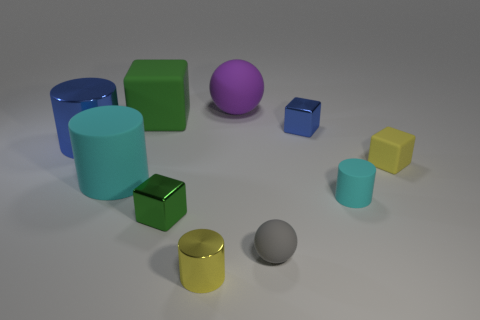What number of tiny things are in front of the big cyan cylinder on the left side of the small gray rubber ball?
Provide a short and direct response. 4. What number of rubber objects are either large things or big gray cylinders?
Offer a very short reply. 3. Is there a purple thing made of the same material as the yellow cube?
Make the answer very short. Yes. How many things are small cubes that are on the left side of the yellow rubber object or tiny objects to the left of the tiny cyan matte object?
Give a very brief answer. 4. There is a rubber ball in front of the purple matte thing; is it the same color as the large matte cube?
Keep it short and to the point. No. What number of other things are there of the same color as the large matte cylinder?
Keep it short and to the point. 1. What is the material of the small blue thing?
Provide a succinct answer. Metal. There is a green object in front of the green rubber thing; is its size the same as the small blue object?
Give a very brief answer. Yes. There is a green rubber object that is the same shape as the small blue object; what is its size?
Your answer should be very brief. Large. Is the number of tiny yellow objects behind the big green object the same as the number of tiny matte things that are to the left of the purple rubber ball?
Keep it short and to the point. Yes. 